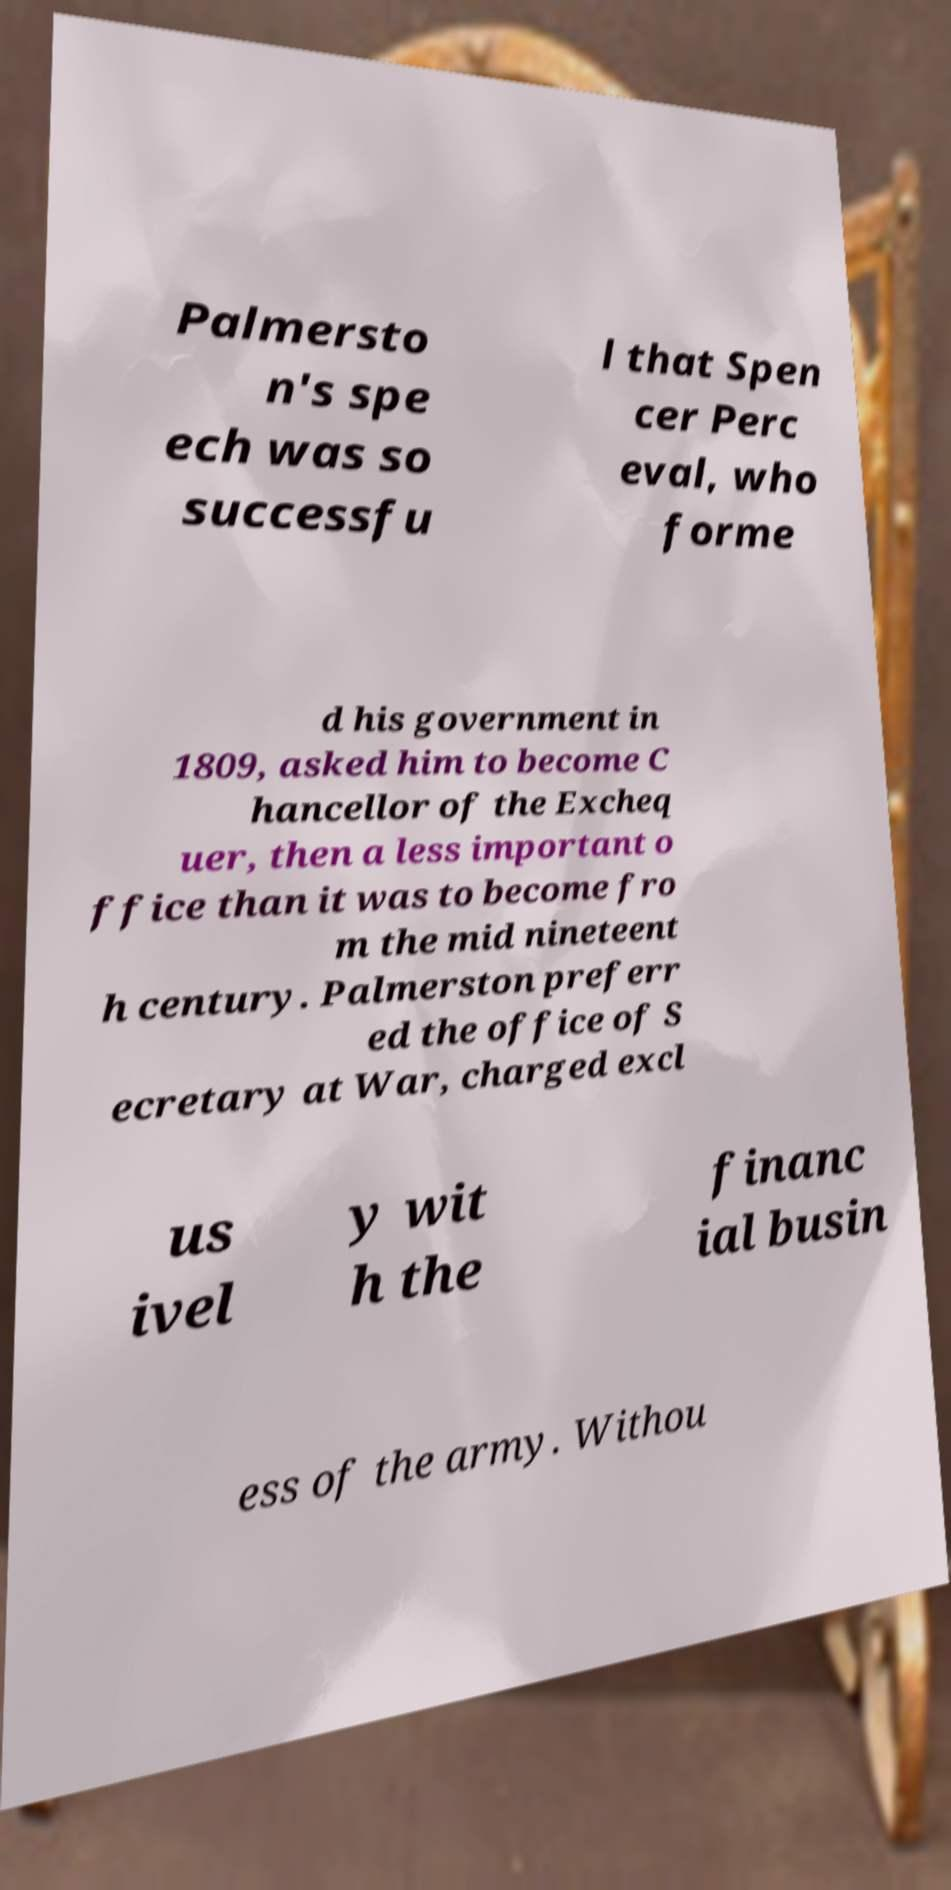Please read and relay the text visible in this image. What does it say? Palmersto n's spe ech was so successfu l that Spen cer Perc eval, who forme d his government in 1809, asked him to become C hancellor of the Excheq uer, then a less important o ffice than it was to become fro m the mid nineteent h century. Palmerston preferr ed the office of S ecretary at War, charged excl us ivel y wit h the financ ial busin ess of the army. Withou 